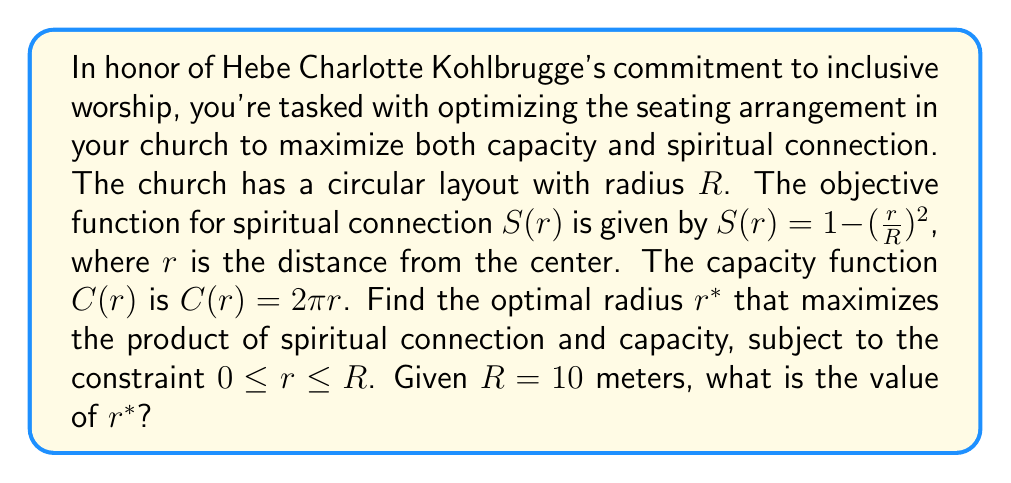Teach me how to tackle this problem. Let's approach this step-by-step:

1) Our objective is to maximize the product of $S(r)$ and $C(r)$. Let's call this product $P(r)$:

   $P(r) = S(r) \cdot C(r) = (1 - (\frac{r}{R})^2) \cdot (2\pi r)$

2) Expanding this:

   $P(r) = 2\pi r - 2\pi (\frac{r^3}{R^2})$

3) To find the maximum, we need to differentiate $P(r)$ with respect to $r$ and set it to zero:

   $\frac{dP}{dr} = 2\pi - 6\pi (\frac{r^2}{R^2}) = 0$

4) Solving this equation:

   $2\pi - 6\pi (\frac{r^2}{R^2}) = 0$
   $2 - 6 (\frac{r^2}{R^2}) = 0$
   $\frac{r^2}{R^2} = \frac{1}{3}$
   $r^2 = \frac{R^2}{3}$
   $r = \frac{R}{\sqrt{3}}$

5) We need to check if this critical point is within our constraint $0 \leq r \leq R$:

   $\frac{R}{\sqrt{3}} \approx 0.577R$, which is indeed between 0 and R.

6) The second derivative of $P(r)$ at this point is negative, confirming it's a maximum.

7) Given $R = 10$ meters, we can calculate $r^*$:

   $r^* = \frac{10}{\sqrt{3}} \approx 5.774$ meters
Answer: $r^* \approx 5.774$ meters 